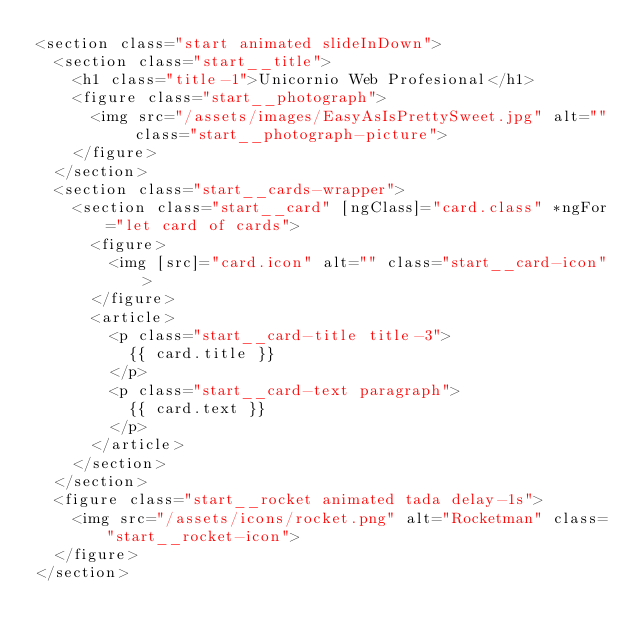Convert code to text. <code><loc_0><loc_0><loc_500><loc_500><_HTML_><section class="start animated slideInDown">
  <section class="start__title">
    <h1 class="title-1">Unicornio Web Profesional</h1>
    <figure class="start__photograph">
      <img src="/assets/images/EasyAsIsPrettySweet.jpg" alt="" class="start__photograph-picture">
    </figure>
  </section>
  <section class="start__cards-wrapper">
    <section class="start__card" [ngClass]="card.class" *ngFor="let card of cards">
      <figure>
        <img [src]="card.icon" alt="" class="start__card-icon">
      </figure>
      <article>
        <p class="start__card-title title-3">
          {{ card.title }}
        </p>
        <p class="start__card-text paragraph">
          {{ card.text }}
        </p>
      </article>
    </section>
  </section>
  <figure class="start__rocket animated tada delay-1s">
    <img src="/assets/icons/rocket.png" alt="Rocketman" class="start__rocket-icon">
  </figure>
</section></code> 